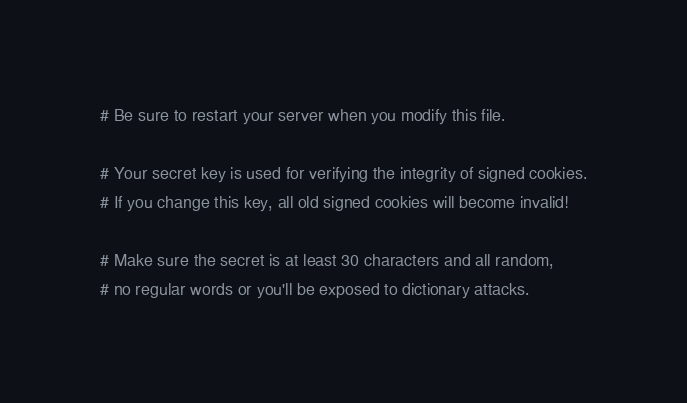<code> <loc_0><loc_0><loc_500><loc_500><_YAML_># Be sure to restart your server when you modify this file.

# Your secret key is used for verifying the integrity of signed cookies.
# If you change this key, all old signed cookies will become invalid!

# Make sure the secret is at least 30 characters and all random,
# no regular words or you'll be exposed to dictionary attacks.</code> 